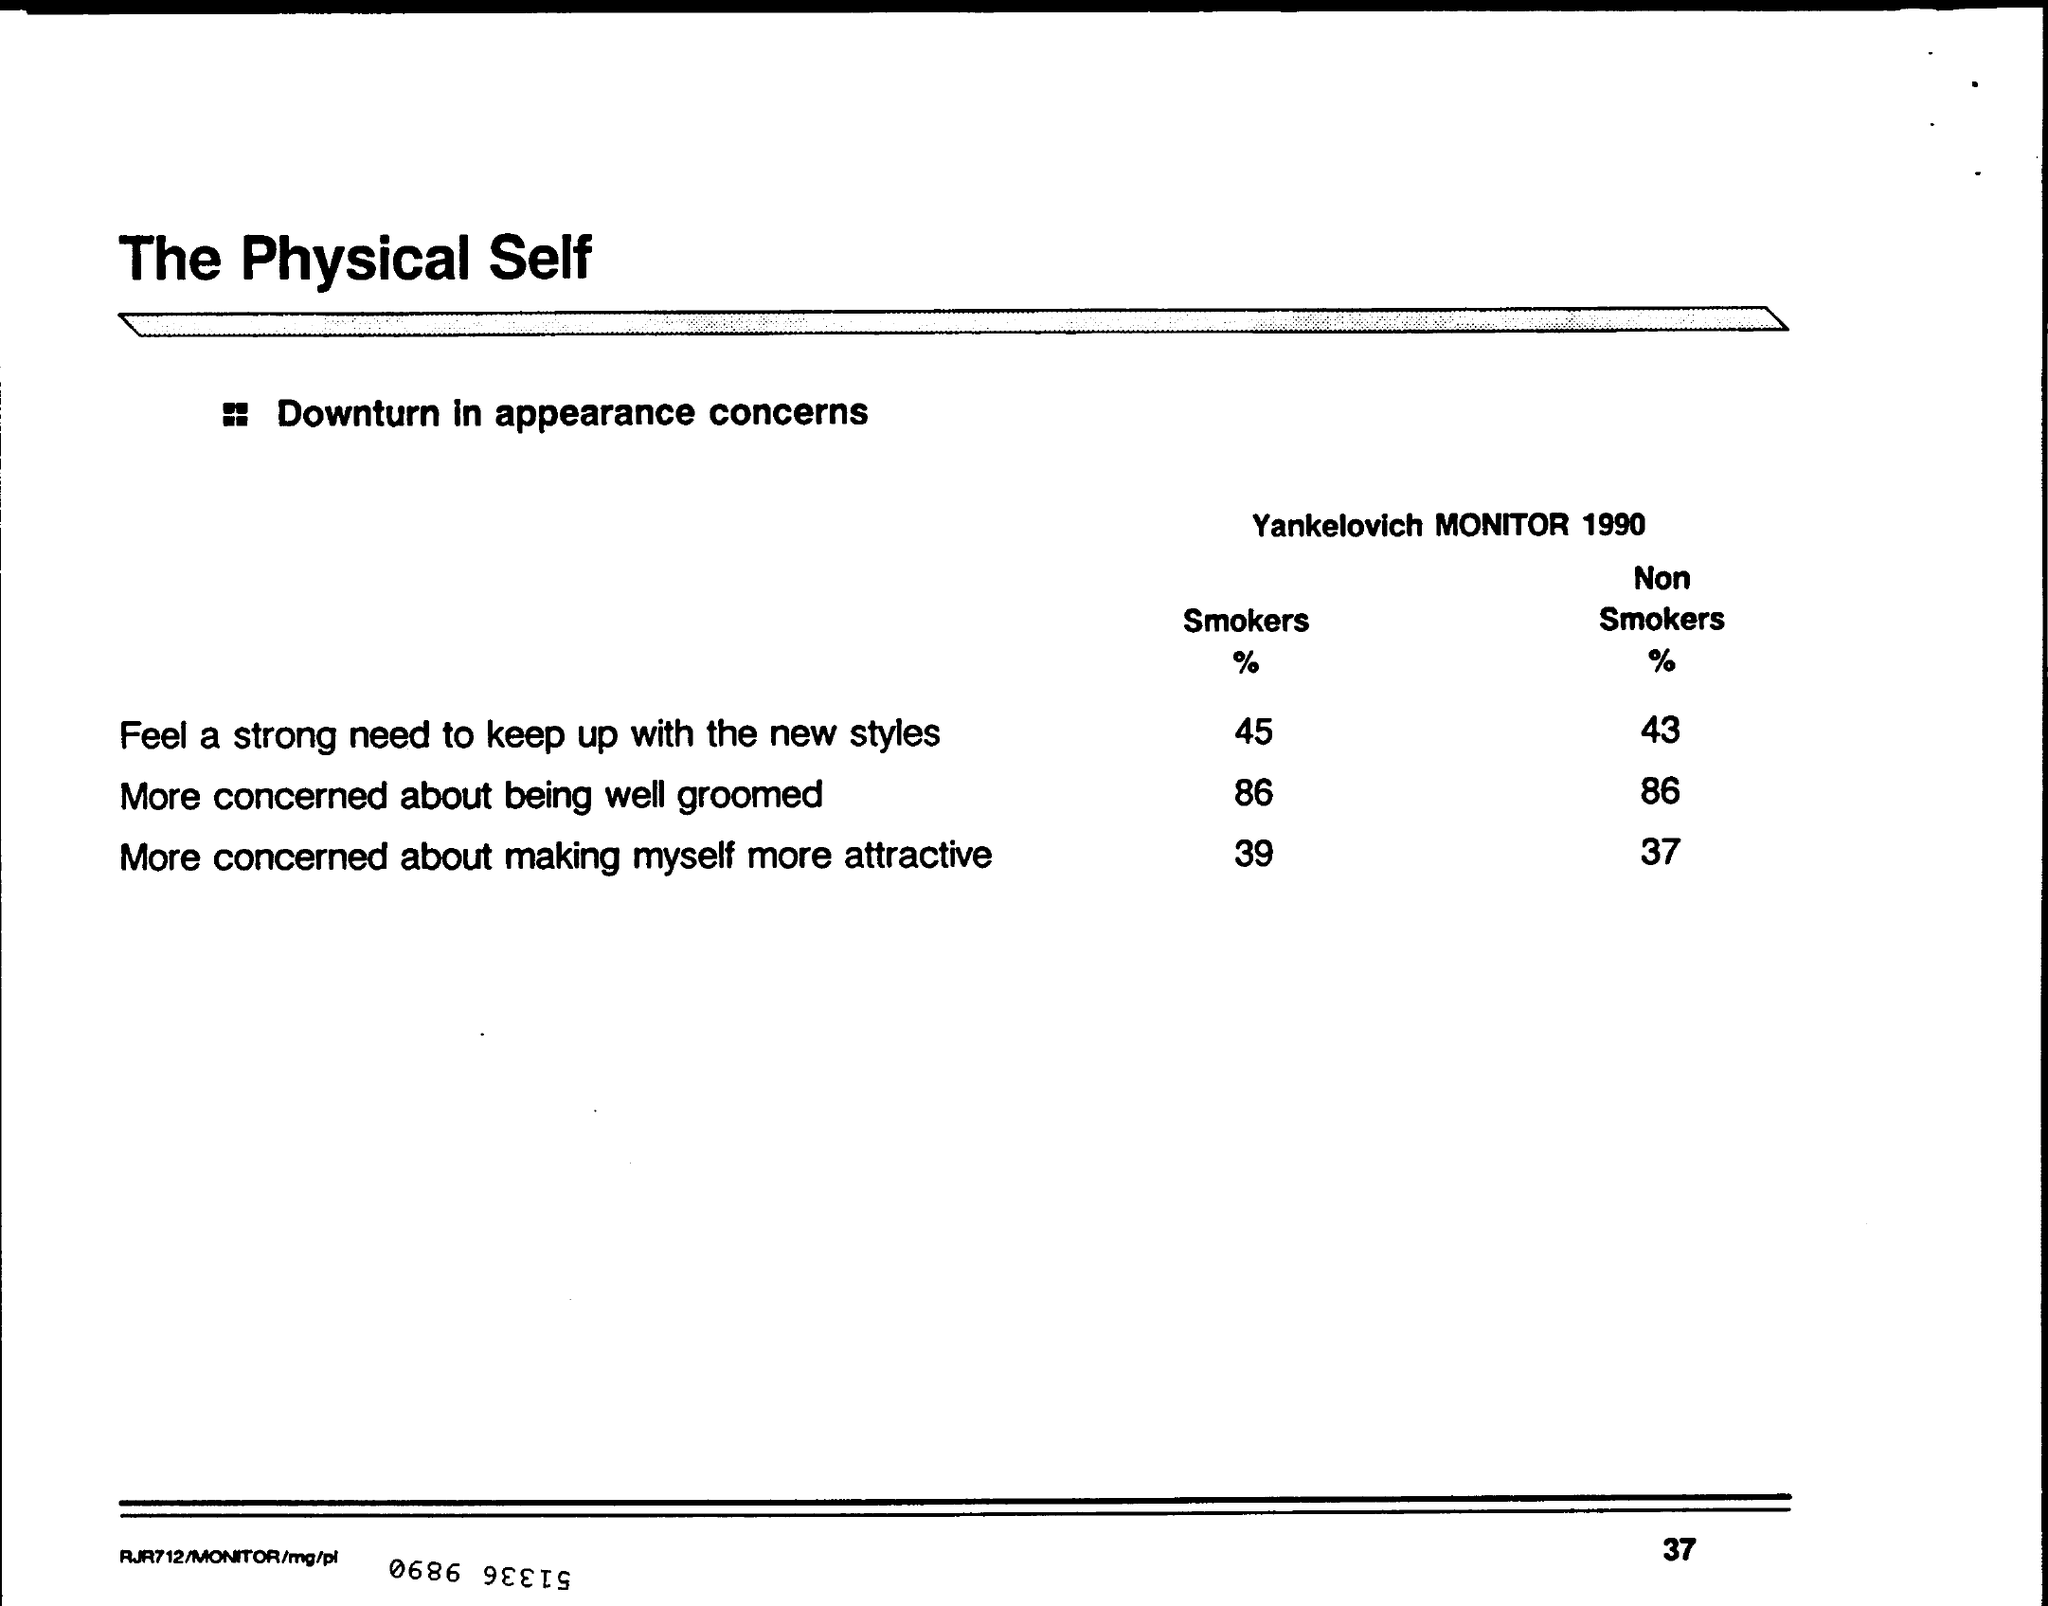What % of Smokers Feel a strong need to keep up with the new styles?
Provide a short and direct response. 45. 